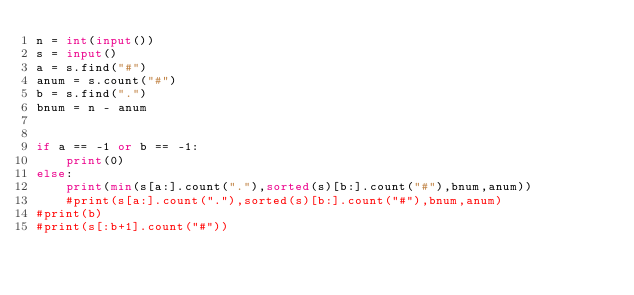Convert code to text. <code><loc_0><loc_0><loc_500><loc_500><_Python_>n = int(input())
s = input()
a = s.find("#")
anum = s.count("#")
b = s.find(".")
bnum = n - anum


if a == -1 or b == -1:
    print(0)
else:
    print(min(s[a:].count("."),sorted(s)[b:].count("#"),bnum,anum))
    #print(s[a:].count("."),sorted(s)[b:].count("#"),bnum,anum)
#print(b)
#print(s[:b+1].count("#"))
</code> 